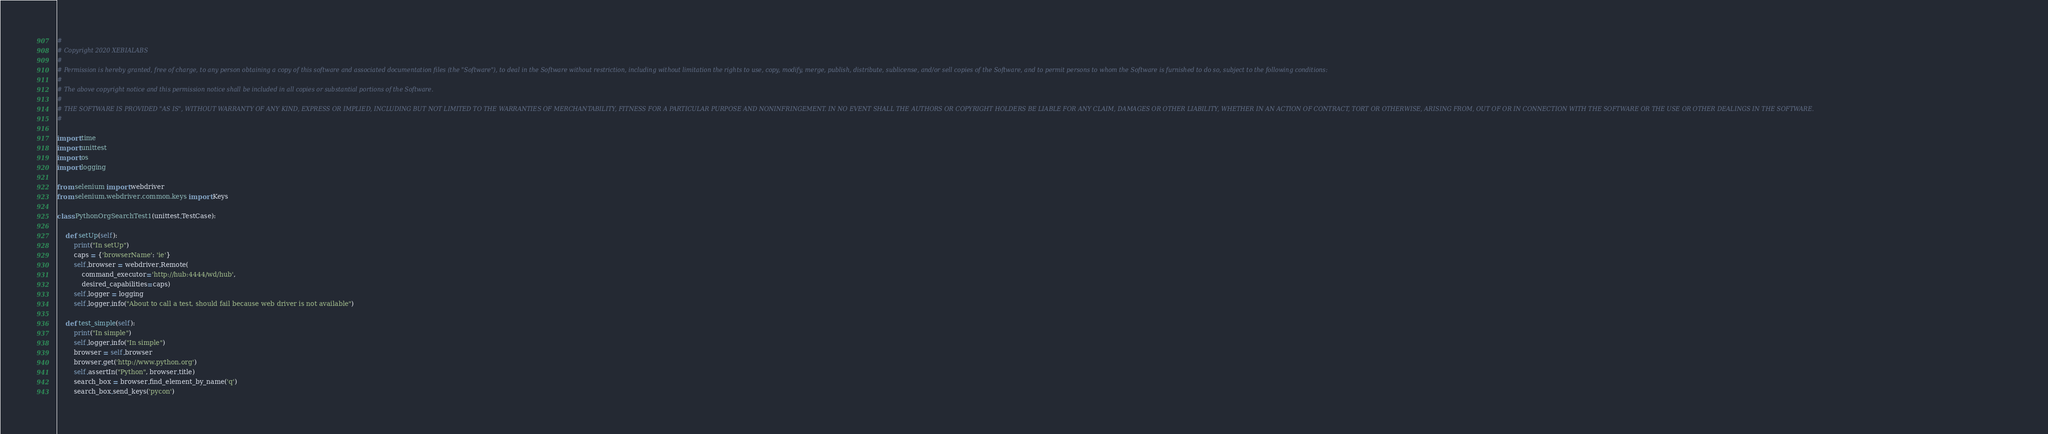<code> <loc_0><loc_0><loc_500><loc_500><_Python_>#
# Copyright 2020 XEBIALABS
#
# Permission is hereby granted, free of charge, to any person obtaining a copy of this software and associated documentation files (the "Software"), to deal in the Software without restriction, including without limitation the rights to use, copy, modify, merge, publish, distribute, sublicense, and/or sell copies of the Software, and to permit persons to whom the Software is furnished to do so, subject to the following conditions:
#
# The above copyright notice and this permission notice shall be included in all copies or substantial portions of the Software.
#
# THE SOFTWARE IS PROVIDED "AS IS", WITHOUT WARRANTY OF ANY KIND, EXPRESS OR IMPLIED, INCLUDING BUT NOT LIMITED TO THE WARRANTIES OF MERCHANTABILITY, FITNESS FOR A PARTICULAR PURPOSE AND NONINFRINGEMENT. IN NO EVENT SHALL THE AUTHORS OR COPYRIGHT HOLDERS BE LIABLE FOR ANY CLAIM, DAMAGES OR OTHER LIABILITY, WHETHER IN AN ACTION OF CONTRACT, TORT OR OTHERWISE, ARISING FROM, OUT OF OR IN CONNECTION WITH THE SOFTWARE OR THE USE OR OTHER DEALINGS IN THE SOFTWARE.
#

import time
import unittest
import os
import logging

from selenium import webdriver
from selenium.webdriver.common.keys import Keys

class PythonOrgSearchTest1(unittest.TestCase):

    def setUp(self):
        print("In setUp")
        caps = {'browserName': 'ie'}
        self.browser = webdriver.Remote(
            command_executor='http://hub:4444/wd/hub',
            desired_capabilities=caps)
        self.logger = logging
        self.logger.info("About to call a test, should fail because web driver is not available")

    def test_simple(self):
        print("In simple")
        self.logger.info("In simple")
        browser = self.browser
        browser.get('http://www.python.org')
        self.assertIn("Python", browser.title)
        search_box = browser.find_element_by_name('q')
        search_box.send_keys('pycon')</code> 